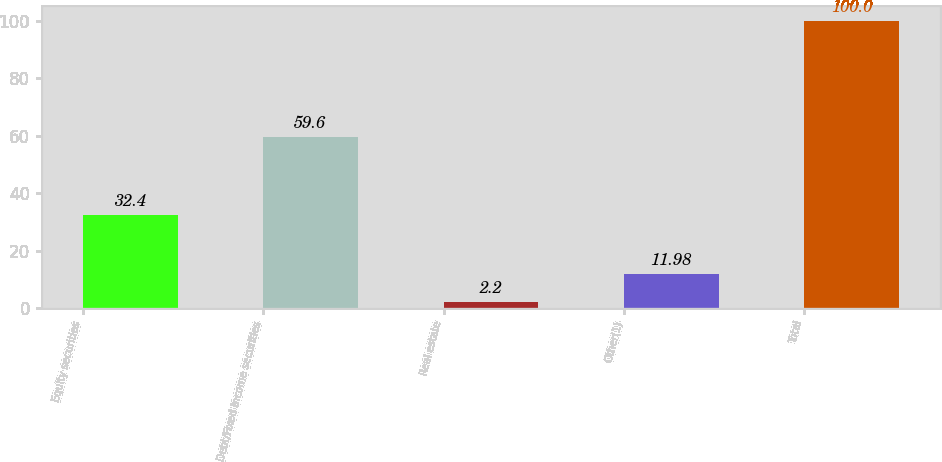Convert chart. <chart><loc_0><loc_0><loc_500><loc_500><bar_chart><fcel>Equity securities<fcel>Debt/Fixed Income securities<fcel>Real estate<fcel>Other(1)<fcel>Total<nl><fcel>32.4<fcel>59.6<fcel>2.2<fcel>11.98<fcel>100<nl></chart> 